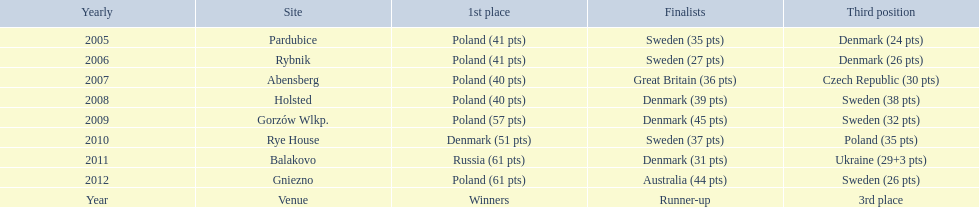What was the difference in final score between russia and denmark in 2011? 30. 